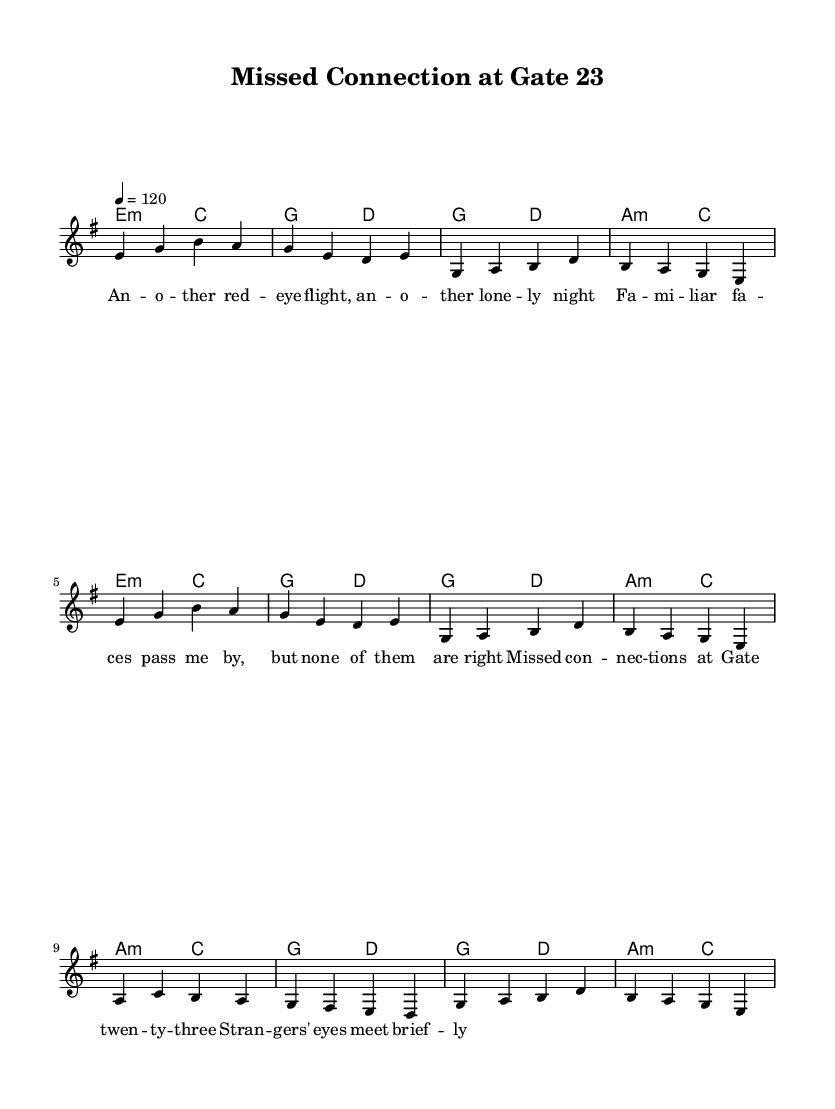What is the key signature of this music? The key signature is determined by the placement of sharps or flats at the beginning of the staff. In this case, there are no sharps or flats indicated, which means it is in E minor, as stated in the provided global music information.
Answer: E minor What is the time signature of this music? The time signature indicates how many beats are in each measure. The sheet music shows a "4/4" time signature, with the top number indicating four beats and the bottom number indicating a quarter note gets one beat.
Answer: 4/4 What is the tempo of the piece? Tempo is indicated in the header section, where it states "4 = 120", meaning there are 120 beats per minute. This gives performers a clear understanding of how fast or slow to play the piece.
Answer: 120 How many verses are in the song structure? The song structure is indicated by the order of the melody sections. The lyrics show a "verse" followed by a "chorus". The order includes two verses before transitioning to the bridge, indicating that there are two verses.
Answer: Two verses What is the primary theme of the lyrics? The lyrics express feelings of loneliness and missed connections, with phrases about a "lone night" and "strangers' eyes meet briefly" suggesting themes of isolation and longing while traveling.
Answer: Loneliness What instrument is primarily featured in the score? The score layout specifies a "new Staff" with a "new Voice" labeled as "lead," indicating that this is the primary instrument or vocal part featured in the sheet music.
Answer: Lead instrument 